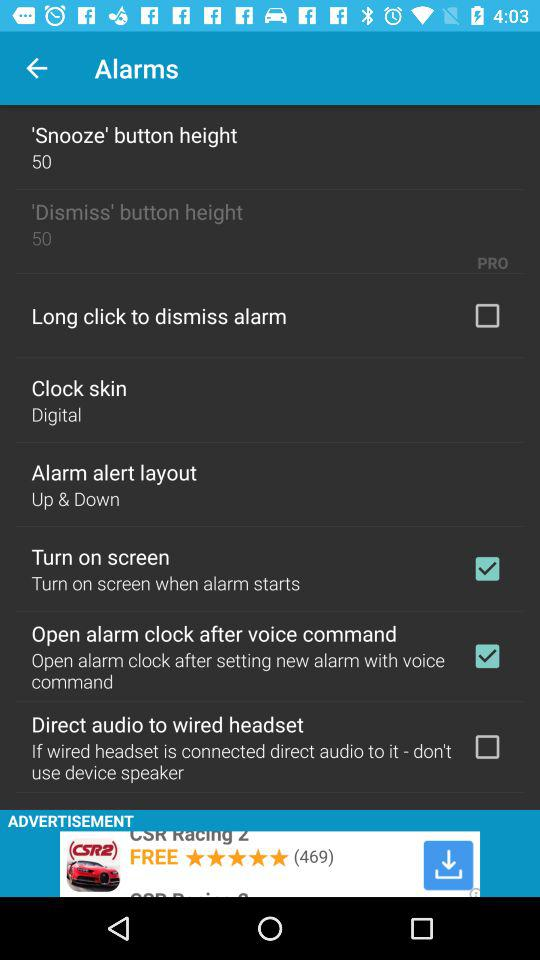What is the current state of "Long click to dismiss alarm"? The current state of "Long click to dismiss alarm" is "off". 